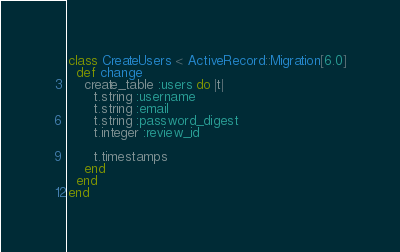<code> <loc_0><loc_0><loc_500><loc_500><_Ruby_>class CreateUsers < ActiveRecord::Migration[6.0]
  def change
    create_table :users do |t|
      t.string :username
      t.string :email
      t.string :password_digest
      t.integer :review_id

      t.timestamps
    end
  end
end
</code> 